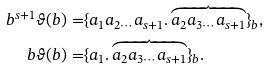<formula> <loc_0><loc_0><loc_500><loc_500>b ^ { s + 1 } \vartheta ( b ) = & \{ a _ { 1 } a _ { 2 \cdots } a _ { s + 1 } . \overbrace { a _ { 2 } a _ { 3 \cdots } a _ { s + 1 } } \} _ { b } , \\ b \vartheta ( b ) = & \{ a _ { 1 } . \overbrace { a _ { 2 } a _ { 3 \cdots } a _ { s + 1 } } \} _ { b } .</formula> 